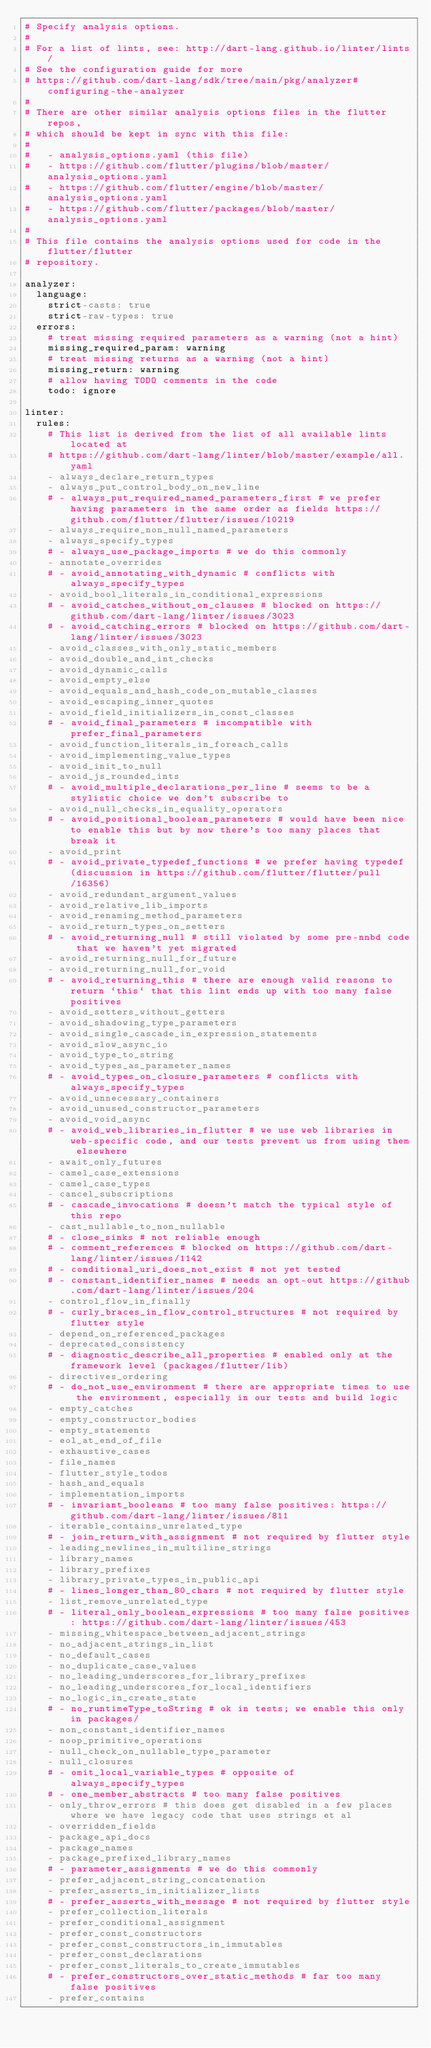<code> <loc_0><loc_0><loc_500><loc_500><_YAML_># Specify analysis options.
#
# For a list of lints, see: http://dart-lang.github.io/linter/lints/
# See the configuration guide for more
# https://github.com/dart-lang/sdk/tree/main/pkg/analyzer#configuring-the-analyzer
#
# There are other similar analysis options files in the flutter repos,
# which should be kept in sync with this file:
#
#   - analysis_options.yaml (this file)
#   - https://github.com/flutter/plugins/blob/master/analysis_options.yaml
#   - https://github.com/flutter/engine/blob/master/analysis_options.yaml
#   - https://github.com/flutter/packages/blob/master/analysis_options.yaml
#
# This file contains the analysis options used for code in the flutter/flutter
# repository.

analyzer:
  language:
    strict-casts: true
    strict-raw-types: true
  errors:
    # treat missing required parameters as a warning (not a hint)
    missing_required_param: warning
    # treat missing returns as a warning (not a hint)
    missing_return: warning
    # allow having TODO comments in the code
    todo: ignore

linter:
  rules:
    # This list is derived from the list of all available lints located at
    # https://github.com/dart-lang/linter/blob/master/example/all.yaml
    - always_declare_return_types
    - always_put_control_body_on_new_line
    # - always_put_required_named_parameters_first # we prefer having parameters in the same order as fields https://github.com/flutter/flutter/issues/10219
    - always_require_non_null_named_parameters
    - always_specify_types
    # - always_use_package_imports # we do this commonly
    - annotate_overrides
    # - avoid_annotating_with_dynamic # conflicts with always_specify_types
    - avoid_bool_literals_in_conditional_expressions
    # - avoid_catches_without_on_clauses # blocked on https://github.com/dart-lang/linter/issues/3023
    # - avoid_catching_errors # blocked on https://github.com/dart-lang/linter/issues/3023
    - avoid_classes_with_only_static_members
    - avoid_double_and_int_checks
    - avoid_dynamic_calls
    - avoid_empty_else
    - avoid_equals_and_hash_code_on_mutable_classes
    - avoid_escaping_inner_quotes
    - avoid_field_initializers_in_const_classes
    # - avoid_final_parameters # incompatible with prefer_final_parameters
    - avoid_function_literals_in_foreach_calls
    - avoid_implementing_value_types
    - avoid_init_to_null
    - avoid_js_rounded_ints
    # - avoid_multiple_declarations_per_line # seems to be a stylistic choice we don't subscribe to
    - avoid_null_checks_in_equality_operators
    # - avoid_positional_boolean_parameters # would have been nice to enable this but by now there's too many places that break it
    - avoid_print
    # - avoid_private_typedef_functions # we prefer having typedef (discussion in https://github.com/flutter/flutter/pull/16356)
    - avoid_redundant_argument_values
    - avoid_relative_lib_imports
    - avoid_renaming_method_parameters
    - avoid_return_types_on_setters
    # - avoid_returning_null # still violated by some pre-nnbd code that we haven't yet migrated
    - avoid_returning_null_for_future
    - avoid_returning_null_for_void
    # - avoid_returning_this # there are enough valid reasons to return `this` that this lint ends up with too many false positives
    - avoid_setters_without_getters
    - avoid_shadowing_type_parameters
    - avoid_single_cascade_in_expression_statements
    - avoid_slow_async_io
    - avoid_type_to_string
    - avoid_types_as_parameter_names
    # - avoid_types_on_closure_parameters # conflicts with always_specify_types
    - avoid_unnecessary_containers
    - avoid_unused_constructor_parameters
    - avoid_void_async
    # - avoid_web_libraries_in_flutter # we use web libraries in web-specific code, and our tests prevent us from using them elsewhere
    - await_only_futures
    - camel_case_extensions
    - camel_case_types
    - cancel_subscriptions
    # - cascade_invocations # doesn't match the typical style of this repo
    - cast_nullable_to_non_nullable
    # - close_sinks # not reliable enough
    # - comment_references # blocked on https://github.com/dart-lang/linter/issues/1142
    # - conditional_uri_does_not_exist # not yet tested
    # - constant_identifier_names # needs an opt-out https://github.com/dart-lang/linter/issues/204
    - control_flow_in_finally
    # - curly_braces_in_flow_control_structures # not required by flutter style
    - depend_on_referenced_packages
    - deprecated_consistency
    # - diagnostic_describe_all_properties # enabled only at the framework level (packages/flutter/lib)
    - directives_ordering
    # - do_not_use_environment # there are appropriate times to use the environment, especially in our tests and build logic
    - empty_catches
    - empty_constructor_bodies
    - empty_statements
    - eol_at_end_of_file
    - exhaustive_cases
    - file_names
    - flutter_style_todos
    - hash_and_equals
    - implementation_imports
    # - invariant_booleans # too many false positives: https://github.com/dart-lang/linter/issues/811
    - iterable_contains_unrelated_type
    # - join_return_with_assignment # not required by flutter style
    - leading_newlines_in_multiline_strings
    - library_names
    - library_prefixes
    - library_private_types_in_public_api
    # - lines_longer_than_80_chars # not required by flutter style
    - list_remove_unrelated_type
    # - literal_only_boolean_expressions # too many false positives: https://github.com/dart-lang/linter/issues/453
    - missing_whitespace_between_adjacent_strings
    - no_adjacent_strings_in_list
    - no_default_cases
    - no_duplicate_case_values
    - no_leading_underscores_for_library_prefixes
    - no_leading_underscores_for_local_identifiers
    - no_logic_in_create_state
    # - no_runtimeType_toString # ok in tests; we enable this only in packages/
    - non_constant_identifier_names
    - noop_primitive_operations
    - null_check_on_nullable_type_parameter
    - null_closures
    # - omit_local_variable_types # opposite of always_specify_types
    # - one_member_abstracts # too many false positives
    - only_throw_errors # this does get disabled in a few places where we have legacy code that uses strings et al
    - overridden_fields
    - package_api_docs
    - package_names
    - package_prefixed_library_names
    # - parameter_assignments # we do this commonly
    - prefer_adjacent_string_concatenation
    - prefer_asserts_in_initializer_lists
    # - prefer_asserts_with_message # not required by flutter style
    - prefer_collection_literals
    - prefer_conditional_assignment
    - prefer_const_constructors
    - prefer_const_constructors_in_immutables
    - prefer_const_declarations
    - prefer_const_literals_to_create_immutables
    # - prefer_constructors_over_static_methods # far too many false positives
    - prefer_contains</code> 